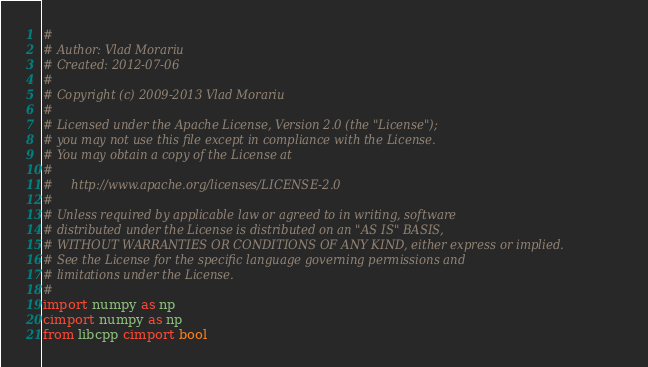Convert code to text. <code><loc_0><loc_0><loc_500><loc_500><_Cython_>#
# Author: Vlad Morariu
# Created: 2012-07-06
#
# Copyright (c) 2009-2013 Vlad Morariu
#
# Licensed under the Apache License, Version 2.0 (the "License");
# you may not use this file except in compliance with the License.
# You may obtain a copy of the License at
#
#     http://www.apache.org/licenses/LICENSE-2.0
#
# Unless required by applicable law or agreed to in writing, software
# distributed under the License is distributed on an "AS IS" BASIS,
# WITHOUT WARRANTIES OR CONDITIONS OF ANY KIND, either express or implied.
# See the License for the specific language governing permissions and
# limitations under the License.
#
import numpy as np
cimport numpy as np
from libcpp cimport bool

</code> 